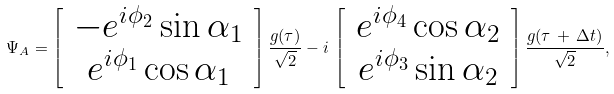<formula> <loc_0><loc_0><loc_500><loc_500>\Psi _ { A } = \left [ \, \begin{array} { c } - e ^ { i \phi _ { 2 } } \sin \alpha _ { 1 } \\ e ^ { i \phi _ { 1 } } \cos \alpha _ { 1 } \end{array} \, \right ] \frac { g ( \tau ) } { \sqrt { 2 } } - i \, \left [ \, \begin{array} { c } e ^ { i \phi _ { 4 } } \cos \alpha _ { 2 } \\ e ^ { i \phi _ { 3 } } \sin \alpha _ { 2 } \end{array} \, \right ] \frac { g ( \tau \, + \, \Delta t ) } { \sqrt { 2 } } ,</formula> 